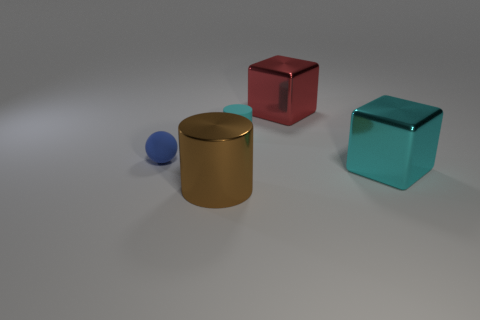Are there any other things that have the same shape as the blue matte object?
Give a very brief answer. No. How many small blue spheres are made of the same material as the brown thing?
Offer a very short reply. 0. Is the number of matte balls in front of the blue matte thing less than the number of large matte spheres?
Your answer should be compact. No. How many tiny balls are there?
Give a very brief answer. 1. How many large blocks have the same color as the small cylinder?
Ensure brevity in your answer.  1. Is the cyan metallic thing the same shape as the small cyan object?
Your answer should be compact. No. There is a metal thing that is right of the large red shiny cube right of the small matte sphere; what size is it?
Offer a terse response. Large. Are there any cyan shiny cubes that have the same size as the red thing?
Make the answer very short. Yes. There is a metallic object behind the cyan cube; does it have the same size as the metallic cube in front of the small sphere?
Offer a terse response. Yes. There is a large thing behind the large metallic cube to the right of the big red metal cube; what is its shape?
Your response must be concise. Cube. 